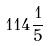<formula> <loc_0><loc_0><loc_500><loc_500>1 1 4 \frac { 1 } { 5 }</formula> 